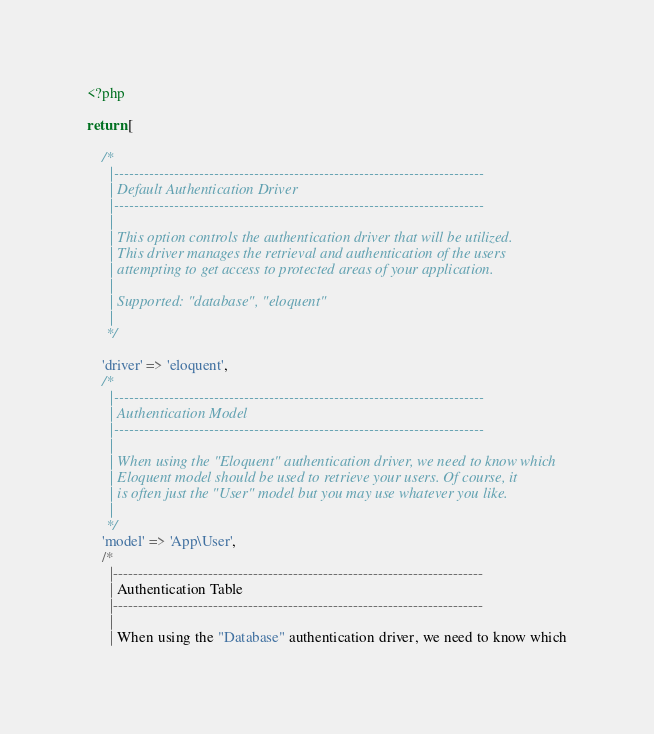<code> <loc_0><loc_0><loc_500><loc_500><_PHP_><?php

return [

    /*
      |--------------------------------------------------------------------------
      | Default Authentication Driver
      |--------------------------------------------------------------------------
      |
      | This option controls the authentication driver that will be utilized.
      | This driver manages the retrieval and authentication of the users
      | attempting to get access to protected areas of your application.
      |
      | Supported: "database", "eloquent"
      |
     */

    'driver' => 'eloquent',
    /*
      |--------------------------------------------------------------------------
      | Authentication Model
      |--------------------------------------------------------------------------
      |
      | When using the "Eloquent" authentication driver, we need to know which
      | Eloquent model should be used to retrieve your users. Of course, it
      | is often just the "User" model but you may use whatever you like.
      |
     */
    'model' => 'App\User',
    /*
      |--------------------------------------------------------------------------
      | Authentication Table
      |--------------------------------------------------------------------------
      |
      | When using the "Database" authentication driver, we need to know which</code> 